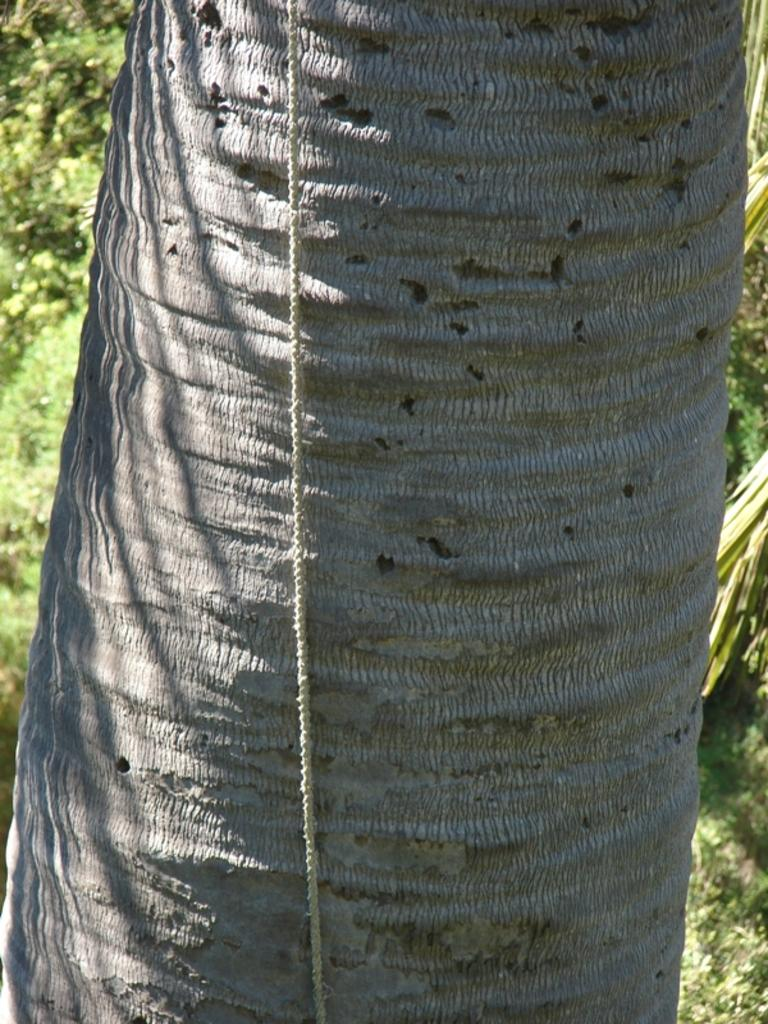What is the main subject of the image? The main subject of the image is the bark of a tree. Are there any objects or features visible on the bark? Yes, there is a white color rope in the image. What can be seen in the background of the image? Trees are visible in the background of the image. What type of food is being prepared on the bark of the tree in the image? There is no food preparation visible in the image; it is a zoom-in of the bark of a tree with a white color rope. What is the tendency of the tree bark to attract certain insects in the image? The image does not provide information about the tendency of the tree bark to attract insects. 